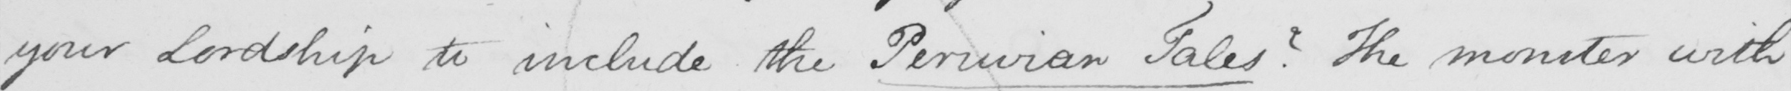What is written in this line of handwriting? your Lordship to include the Peruvian Tales ?  The monster with 